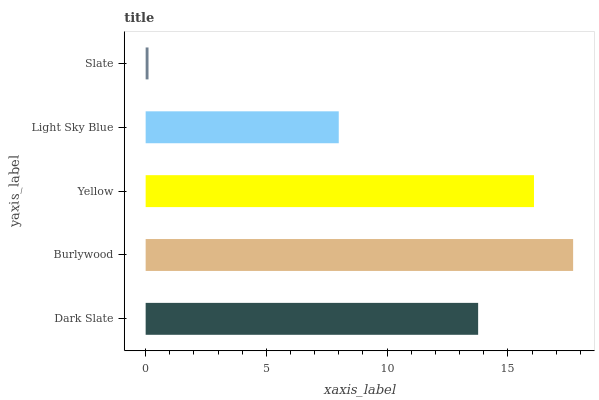Is Slate the minimum?
Answer yes or no. Yes. Is Burlywood the maximum?
Answer yes or no. Yes. Is Yellow the minimum?
Answer yes or no. No. Is Yellow the maximum?
Answer yes or no. No. Is Burlywood greater than Yellow?
Answer yes or no. Yes. Is Yellow less than Burlywood?
Answer yes or no. Yes. Is Yellow greater than Burlywood?
Answer yes or no. No. Is Burlywood less than Yellow?
Answer yes or no. No. Is Dark Slate the high median?
Answer yes or no. Yes. Is Dark Slate the low median?
Answer yes or no. Yes. Is Burlywood the high median?
Answer yes or no. No. Is Yellow the low median?
Answer yes or no. No. 